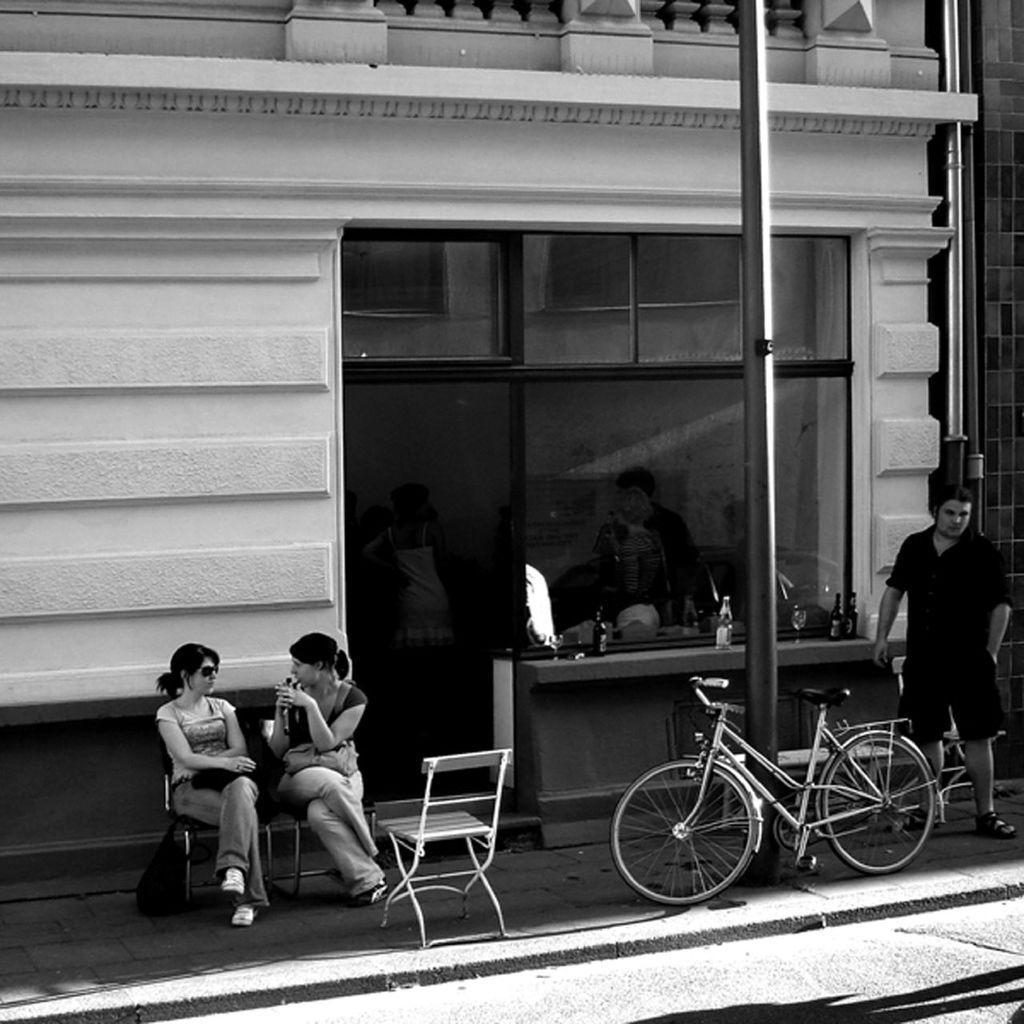Can you describe this image briefly? In the picture we can see a building with a glass window and outside it, we can see a some chairs with two women sitting on the chairs and besides, we can see a pole and a bicycle near it and behind we can see a man standing on the path. 